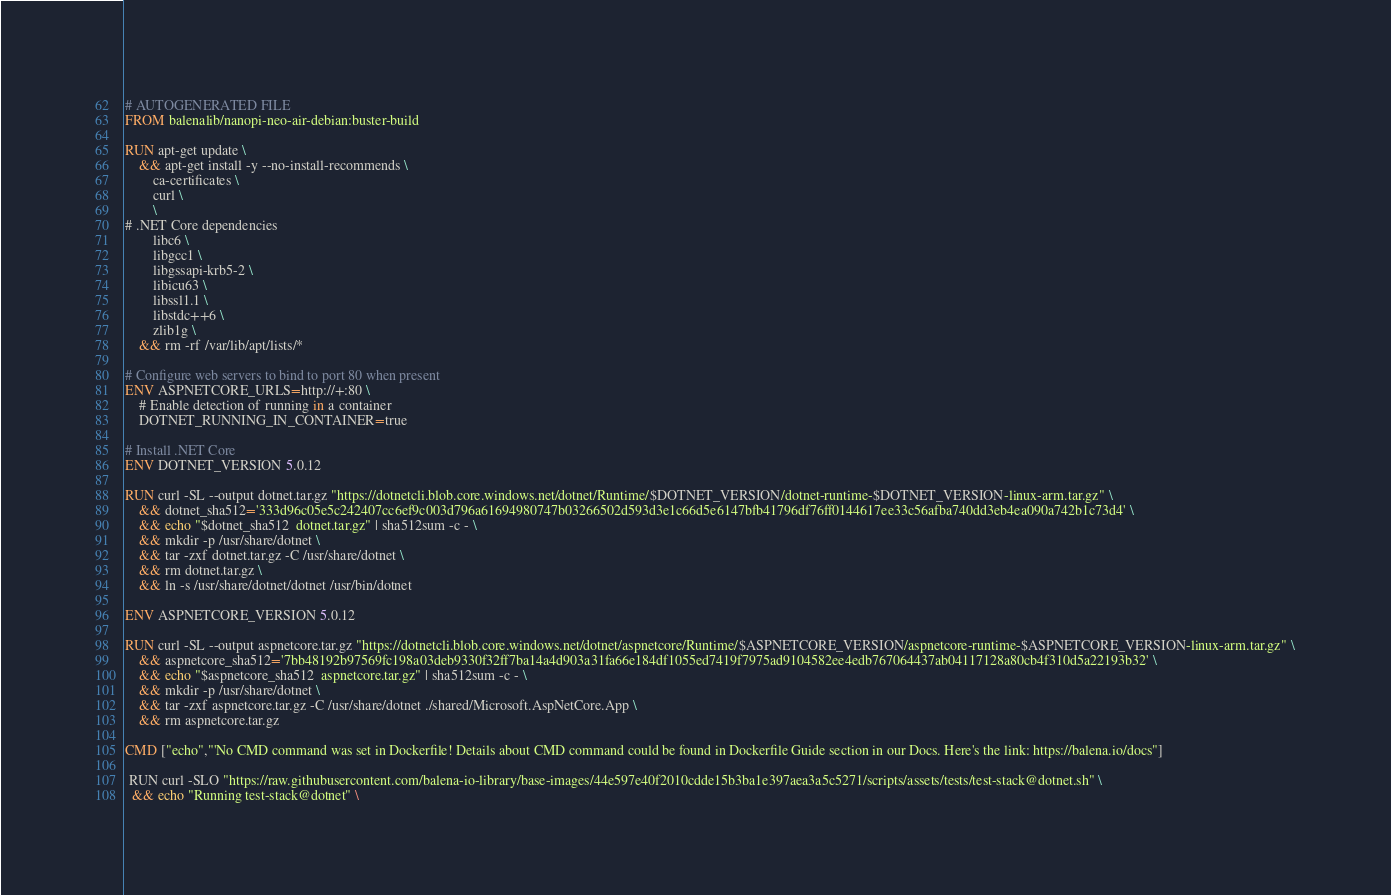Convert code to text. <code><loc_0><loc_0><loc_500><loc_500><_Dockerfile_># AUTOGENERATED FILE
FROM balenalib/nanopi-neo-air-debian:buster-build

RUN apt-get update \
    && apt-get install -y --no-install-recommends \
        ca-certificates \
        curl \
        \
# .NET Core dependencies
        libc6 \
        libgcc1 \
        libgssapi-krb5-2 \
        libicu63 \
        libssl1.1 \
        libstdc++6 \
        zlib1g \
    && rm -rf /var/lib/apt/lists/*

# Configure web servers to bind to port 80 when present
ENV ASPNETCORE_URLS=http://+:80 \
    # Enable detection of running in a container
    DOTNET_RUNNING_IN_CONTAINER=true

# Install .NET Core
ENV DOTNET_VERSION 5.0.12

RUN curl -SL --output dotnet.tar.gz "https://dotnetcli.blob.core.windows.net/dotnet/Runtime/$DOTNET_VERSION/dotnet-runtime-$DOTNET_VERSION-linux-arm.tar.gz" \
    && dotnet_sha512='333d96c05e5c242407cc6ef9c003d796a61694980747b03266502d593d3e1c66d5e6147bfb41796df76ff0144617ee33c56afba740dd3eb4ea090a742b1c73d4' \
    && echo "$dotnet_sha512  dotnet.tar.gz" | sha512sum -c - \
    && mkdir -p /usr/share/dotnet \
    && tar -zxf dotnet.tar.gz -C /usr/share/dotnet \
    && rm dotnet.tar.gz \
    && ln -s /usr/share/dotnet/dotnet /usr/bin/dotnet

ENV ASPNETCORE_VERSION 5.0.12

RUN curl -SL --output aspnetcore.tar.gz "https://dotnetcli.blob.core.windows.net/dotnet/aspnetcore/Runtime/$ASPNETCORE_VERSION/aspnetcore-runtime-$ASPNETCORE_VERSION-linux-arm.tar.gz" \
    && aspnetcore_sha512='7bb48192b97569fc198a03deb9330f32ff7ba14a4d903a31fa66e184df1055ed7419f7975ad9104582ee4edb767064437ab04117128a80cb4f310d5a22193b32' \
    && echo "$aspnetcore_sha512  aspnetcore.tar.gz" | sha512sum -c - \
    && mkdir -p /usr/share/dotnet \
    && tar -zxf aspnetcore.tar.gz -C /usr/share/dotnet ./shared/Microsoft.AspNetCore.App \
    && rm aspnetcore.tar.gz

CMD ["echo","'No CMD command was set in Dockerfile! Details about CMD command could be found in Dockerfile Guide section in our Docs. Here's the link: https://balena.io/docs"]

 RUN curl -SLO "https://raw.githubusercontent.com/balena-io-library/base-images/44e597e40f2010cdde15b3ba1e397aea3a5c5271/scripts/assets/tests/test-stack@dotnet.sh" \
  && echo "Running test-stack@dotnet" \</code> 